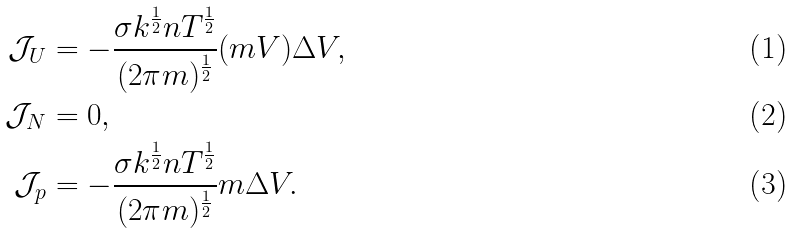Convert formula to latex. <formula><loc_0><loc_0><loc_500><loc_500>\mathcal { J } _ { U } & = - \frac { \sigma k ^ { \frac { 1 } { 2 } } n T ^ { \frac { 1 } { 2 } } } { ( 2 \pi m ) ^ { \frac { 1 } { 2 } } } ( m V ) \Delta V , \\ \mathcal { J } _ { N } & = 0 , \\ \mathcal { J } _ { p } & = - \frac { \sigma k ^ { \frac { 1 } { 2 } } n T ^ { \frac { 1 } { 2 } } } { ( 2 \pi m ) ^ { \frac { 1 } { 2 } } } m \Delta V .</formula> 